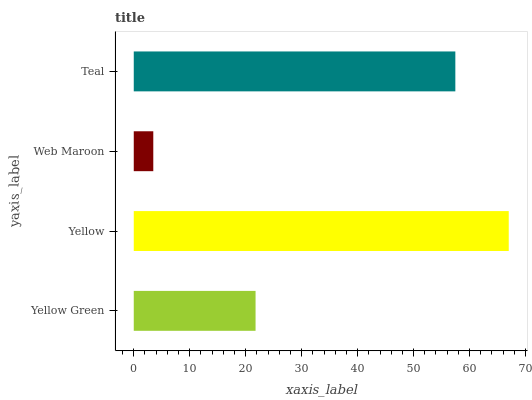Is Web Maroon the minimum?
Answer yes or no. Yes. Is Yellow the maximum?
Answer yes or no. Yes. Is Yellow the minimum?
Answer yes or no. No. Is Web Maroon the maximum?
Answer yes or no. No. Is Yellow greater than Web Maroon?
Answer yes or no. Yes. Is Web Maroon less than Yellow?
Answer yes or no. Yes. Is Web Maroon greater than Yellow?
Answer yes or no. No. Is Yellow less than Web Maroon?
Answer yes or no. No. Is Teal the high median?
Answer yes or no. Yes. Is Yellow Green the low median?
Answer yes or no. Yes. Is Yellow the high median?
Answer yes or no. No. Is Teal the low median?
Answer yes or no. No. 